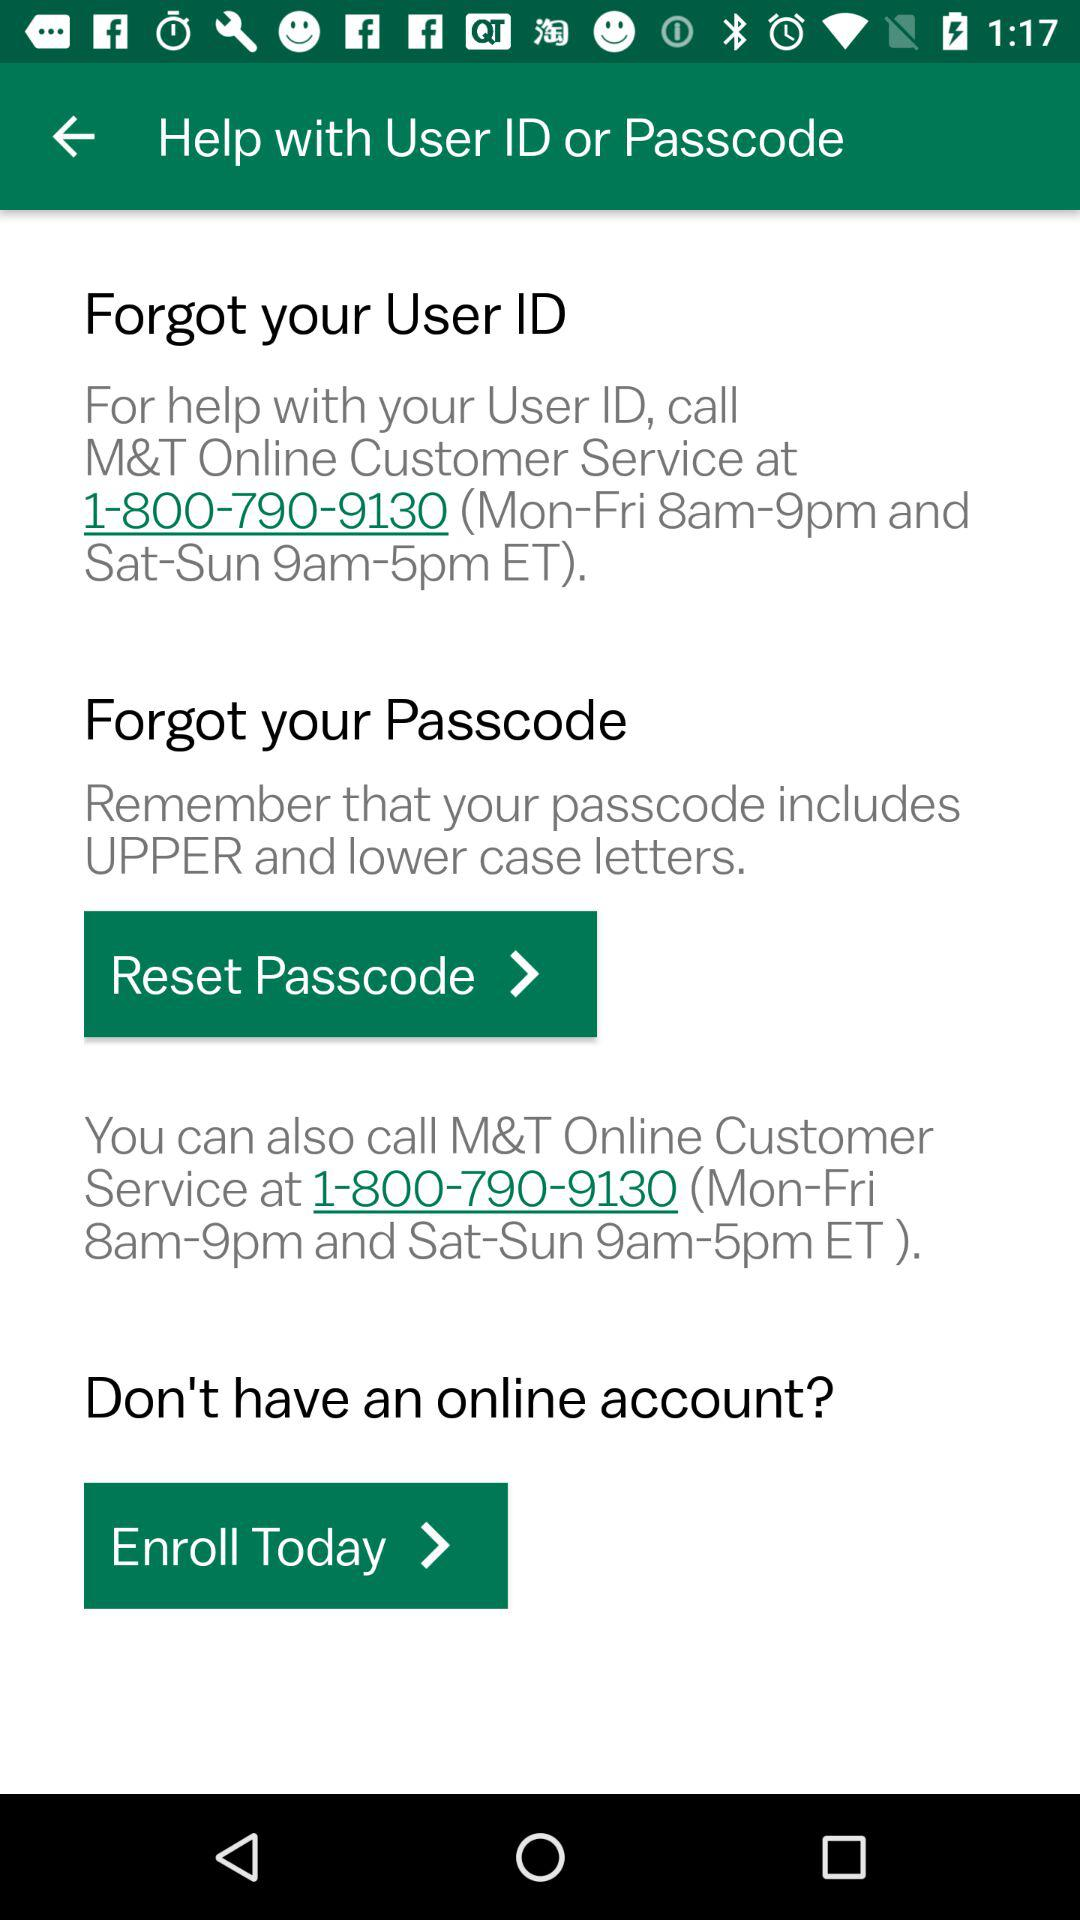What is the online customer service number? The online customer service number is 1-800-790-9130. 